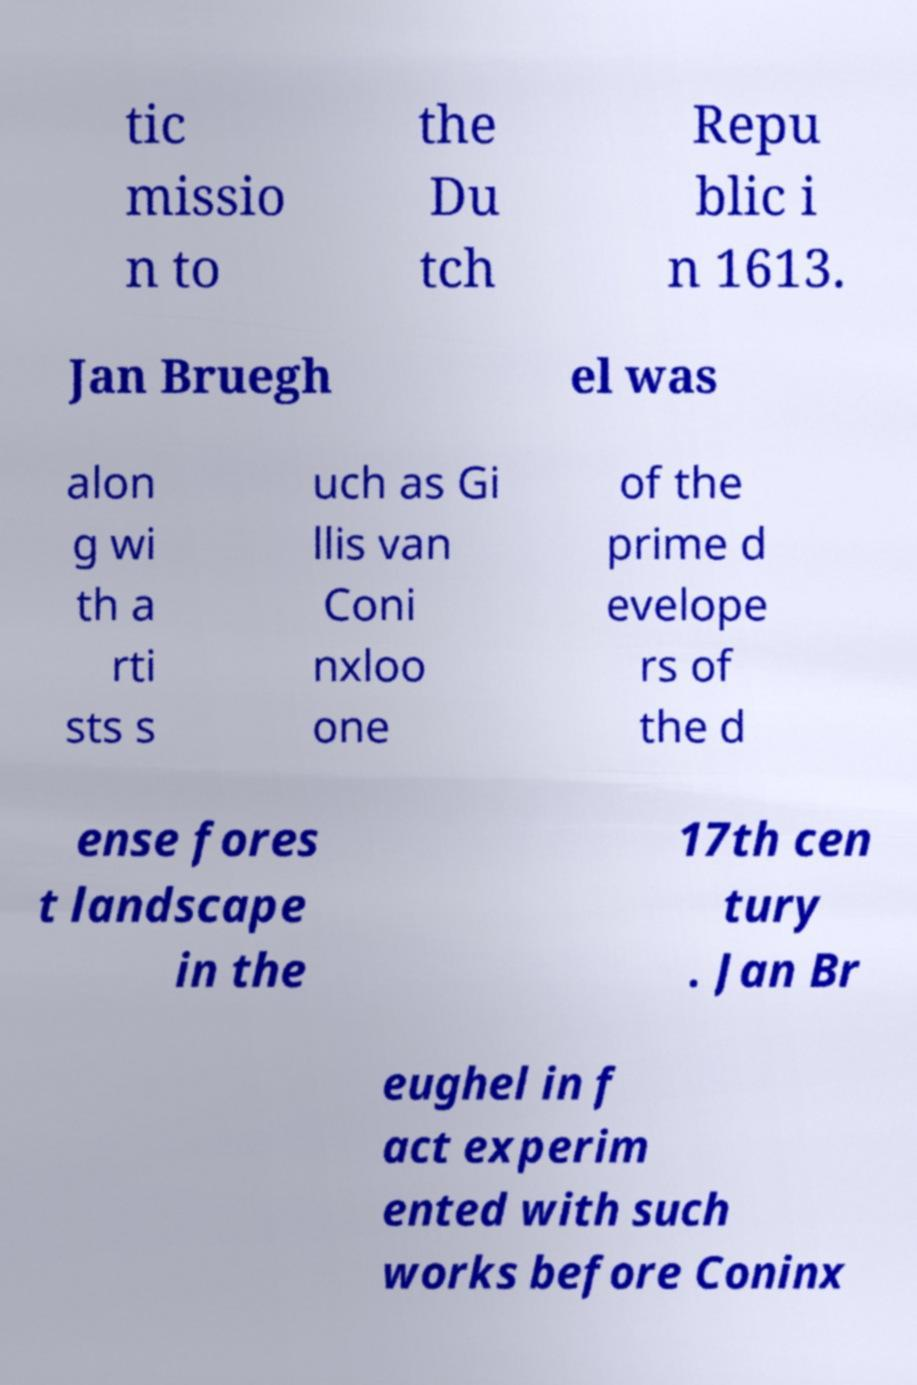Could you extract and type out the text from this image? tic missio n to the Du tch Repu blic i n 1613. Jan Bruegh el was alon g wi th a rti sts s uch as Gi llis van Coni nxloo one of the prime d evelope rs of the d ense fores t landscape in the 17th cen tury . Jan Br eughel in f act experim ented with such works before Coninx 